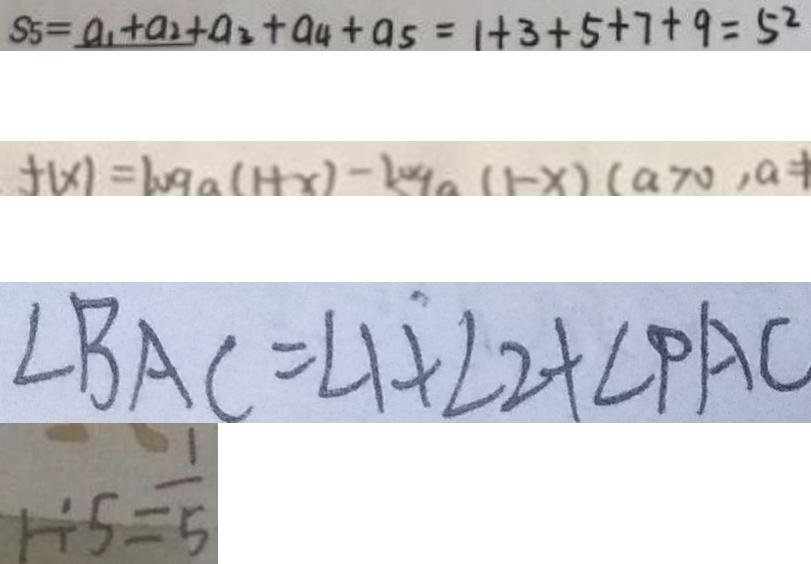<formula> <loc_0><loc_0><loc_500><loc_500>S _ { 5 } = a _ { 1 } + a _ { 2 } + a _ { 3 } + a _ { 4 } + a _ { 5 } = 1 + 3 + 5 + 7 + 9 = 5 ^ { 2 } 
 f ( x ) = \log a ( 1 + x ) - \log a ( 1 - x ) ( a > 0 , a = 1 
 \angle B A C = \angle 1 + \angle 2 + \angle P A C 
 1 \div 5 = \frac { 1 } { 5 }</formula> 